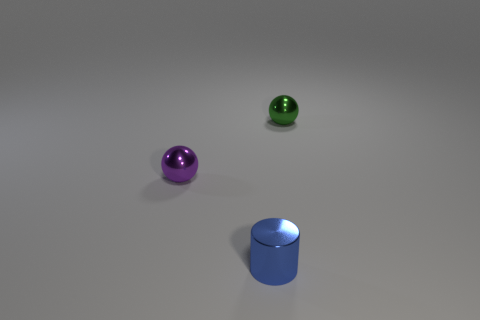There is a metal object that is to the right of the purple sphere and behind the tiny metal cylinder; what is its shape?
Your answer should be very brief. Sphere. Does the sphere that is to the left of the green object have the same material as the small blue object?
Your answer should be very brief. Yes. What is the color of the metallic sphere that is the same size as the purple object?
Offer a terse response. Green. There is a blue object that is in front of the small object that is behind the tiny sphere left of the green ball; what is its shape?
Your answer should be compact. Cylinder. What number of things are either small purple metallic balls or spheres that are left of the tiny blue cylinder?
Offer a terse response. 1. What number of things are tiny balls that are on the left side of the tiny blue thing or small spheres that are on the left side of the cylinder?
Your answer should be very brief. 1. Are there any tiny green shiny things on the right side of the purple object?
Provide a succinct answer. Yes. There is a tiny ball that is in front of the object that is behind the tiny sphere that is on the left side of the tiny cylinder; what is its color?
Your response must be concise. Purple. Is the shape of the small purple metal thing the same as the blue object?
Make the answer very short. No. The small cylinder that is made of the same material as the purple object is what color?
Your response must be concise. Blue. 